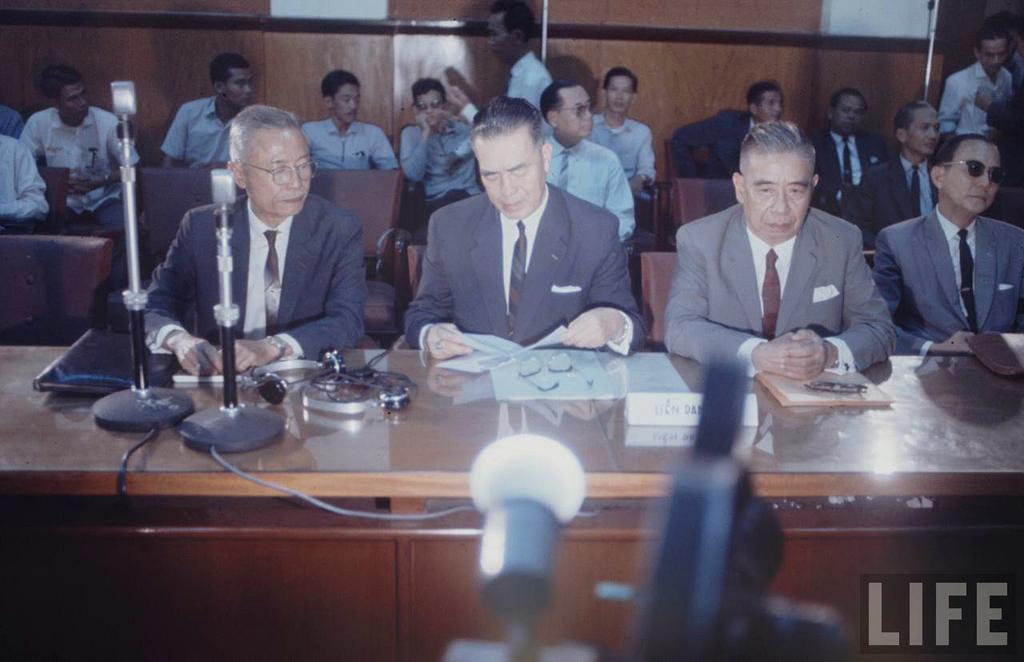In one or two sentences, can you explain what this image depicts? In this image I can see a group of people are sitting on a chair in front of a table. On the table I can see there is a microphone and other objects on it. 